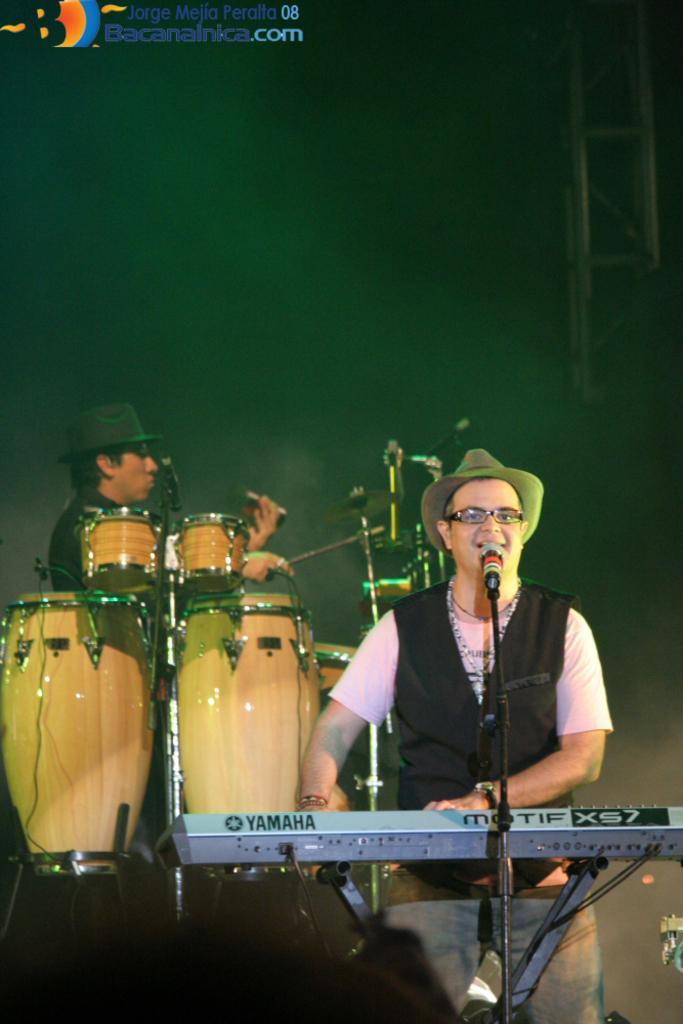Please provide a concise description of this image. In this image there is a person standing and playing music keyboard and he is singing. At the back there is a person playing drums. 